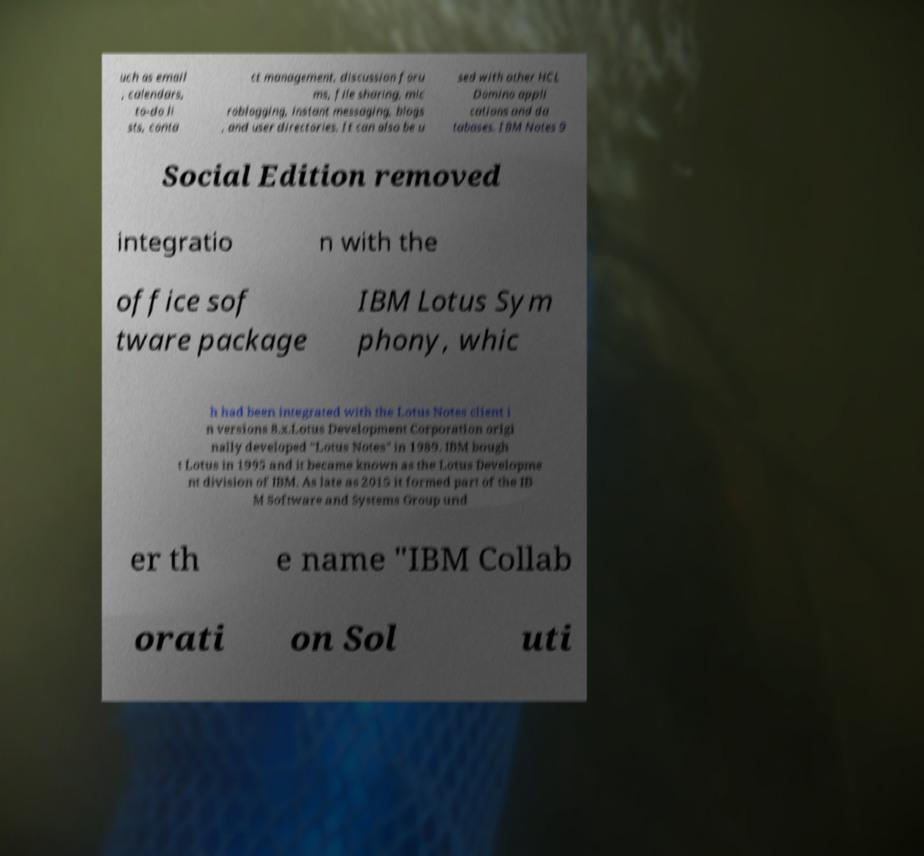Can you read and provide the text displayed in the image?This photo seems to have some interesting text. Can you extract and type it out for me? uch as email , calendars, to-do li sts, conta ct management, discussion foru ms, file sharing, mic roblogging, instant messaging, blogs , and user directories. It can also be u sed with other HCL Domino appli cations and da tabases. IBM Notes 9 Social Edition removed integratio n with the office sof tware package IBM Lotus Sym phony, whic h had been integrated with the Lotus Notes client i n versions 8.x.Lotus Development Corporation origi nally developed "Lotus Notes" in 1989. IBM bough t Lotus in 1995 and it became known as the Lotus Developme nt division of IBM. As late as 2015 it formed part of the IB M Software and Systems Group und er th e name "IBM Collab orati on Sol uti 